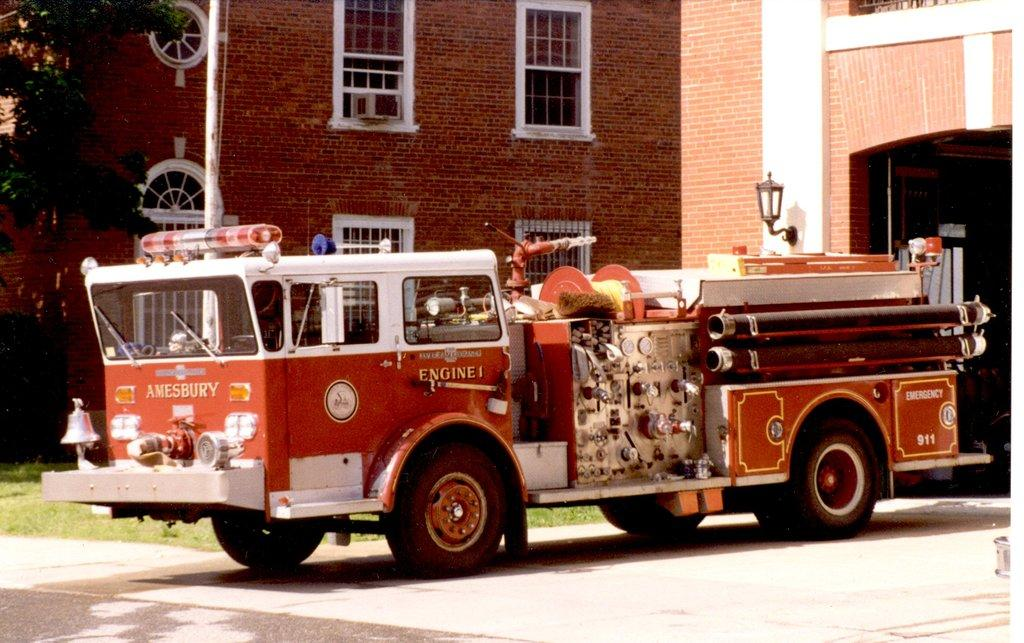What type of vehicle is on the ground in the image? The facts do not specify the type of vehicle, but there is a vehicle on the ground in the image. What can be seen growing on the ground in the image? There is grass visible in the image. What type of plant is in the image? There is a tree in the image. What type of structure is in the image? There is a building with windows in the image. What else can be seen in the image besides the vehicle, grass, tree, and building? There are some objects in the image. Reasoning: Let' Let's think step by step in order to produce the conversation. We start by identifying the main subjects and objects in the image based on the provided facts. We then formulate questions that focus on the location and characteristics of these subjects and objects, ensuring that each question can be answered definitively with the information given. We avoid yes/no questions and ensure that the language is simple and clear. Absurd Question/Answer: What type of pest can be seen crawling on the vehicle in the image? There is no mention of a pest in the image. --- Facts: 1. There is a person in the image. 2. The person is wearing a hat. 3. The person is holding a book. 4. There is a table in the image. 5. There is a chair in the image. Absurd Topics: elephant, ocean Conversation: Who or what is in the image? There is a person in the image. What is the person wearing in the image? The person is wearing a hat in the image. What is the person holding in the image? The person is holding a book in the image. What type of furniture is in the image? There is a table and a chair in the image. Can you see an elephant swimming in the ocean in the image? There is no mention of an elephant or the ocean in the image. 